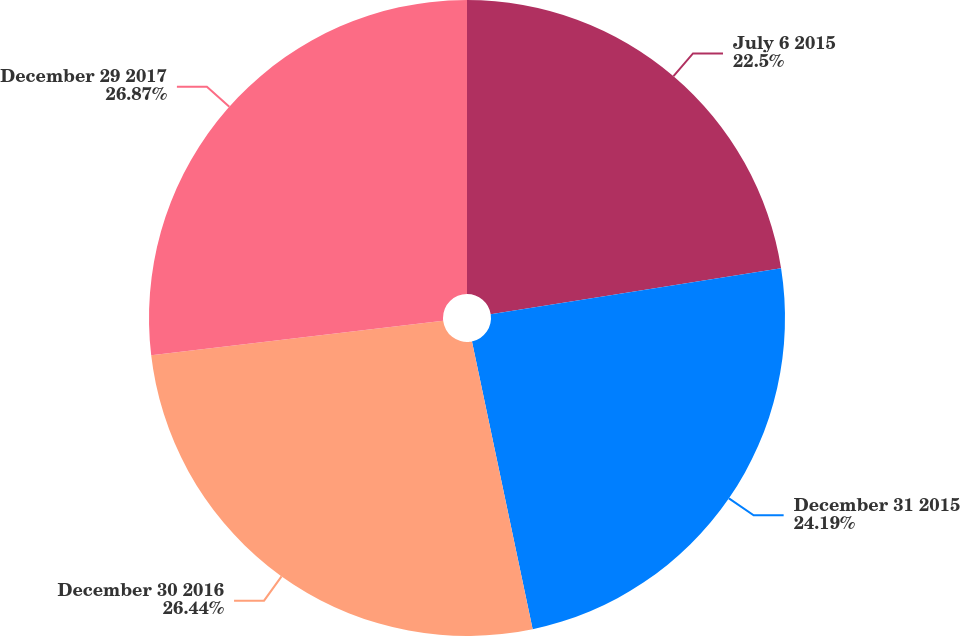<chart> <loc_0><loc_0><loc_500><loc_500><pie_chart><fcel>July 6 2015<fcel>December 31 2015<fcel>December 30 2016<fcel>December 29 2017<nl><fcel>22.5%<fcel>24.19%<fcel>26.44%<fcel>26.87%<nl></chart> 